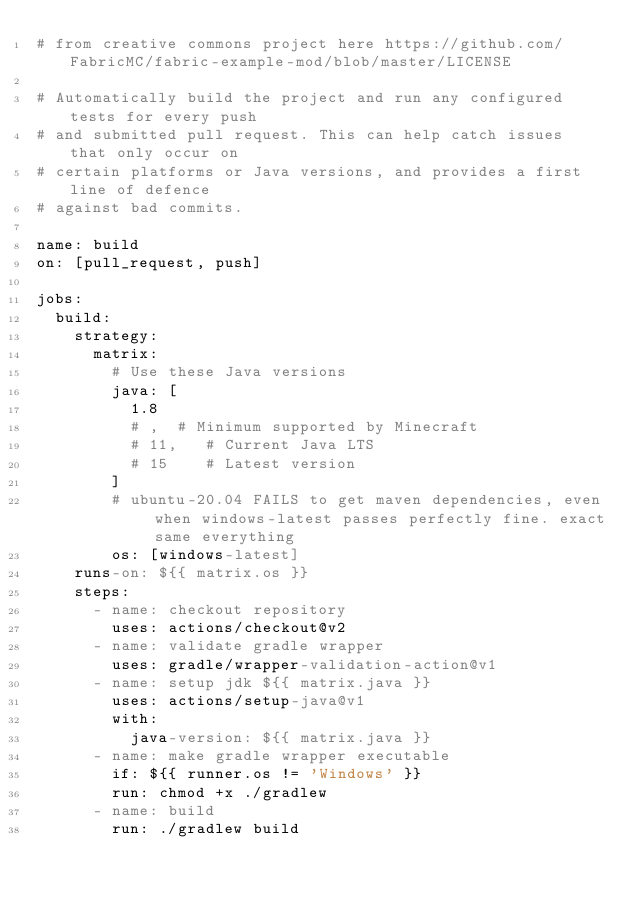Convert code to text. <code><loc_0><loc_0><loc_500><loc_500><_YAML_># from creative commons project here https://github.com/FabricMC/fabric-example-mod/blob/master/LICENSE

# Automatically build the project and run any configured tests for every push
# and submitted pull request. This can help catch issues that only occur on
# certain platforms or Java versions, and provides a first line of defence
# against bad commits.

name: build
on: [pull_request, push]

jobs:
  build:
    strategy:
      matrix:
        # Use these Java versions
        java: [
          1.8
          # ,  # Minimum supported by Minecraft
          # 11,   # Current Java LTS
          # 15    # Latest version
        ]
        # ubuntu-20.04 FAILS to get maven dependencies, even when windows-latest passes perfectly fine. exact same everything
        os: [windows-latest]
    runs-on: ${{ matrix.os }}
    steps:
      - name: checkout repository
        uses: actions/checkout@v2
      - name: validate gradle wrapper
        uses: gradle/wrapper-validation-action@v1
      - name: setup jdk ${{ matrix.java }}
        uses: actions/setup-java@v1
        with:
          java-version: ${{ matrix.java }}
      - name: make gradle wrapper executable
        if: ${{ runner.os != 'Windows' }}
        run: chmod +x ./gradlew
      - name: build
        run: ./gradlew build
</code> 